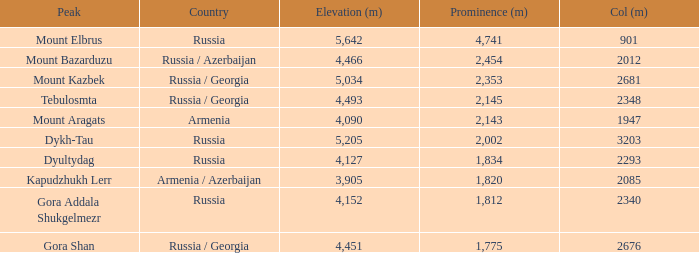What is the Col (m) of Peak Mount Aragats with an Elevation (m) larger than 3,905 and Prominence smaller than 2,143? None. 